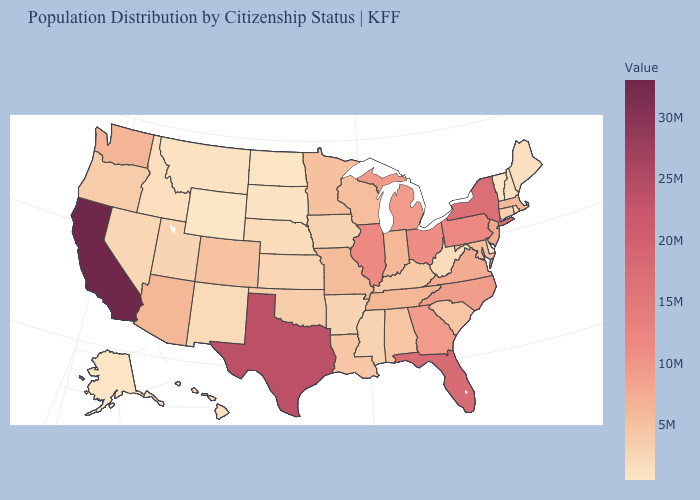Does South Dakota have the lowest value in the MidWest?
Answer briefly. No. Does the map have missing data?
Give a very brief answer. No. Does Connecticut have the lowest value in the USA?
Short answer required. No. Does Maryland have the highest value in the USA?
Give a very brief answer. No. Which states have the lowest value in the USA?
Keep it brief. Wyoming. Among the states that border North Carolina , which have the lowest value?
Give a very brief answer. South Carolina. 